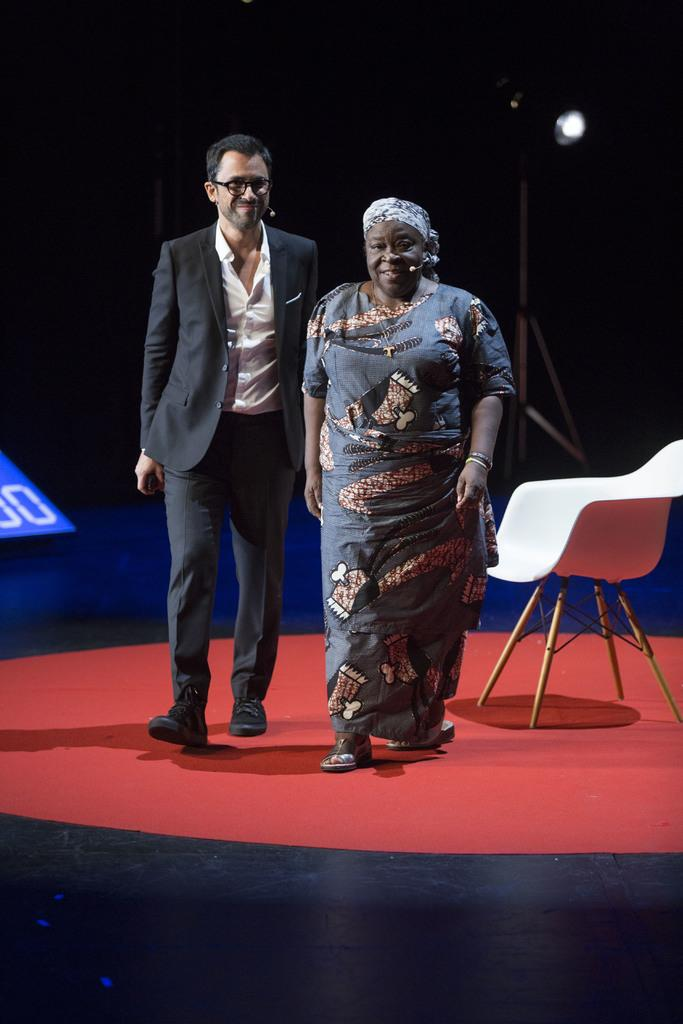What types of people are present in the image? There are women and men in the image. What are the women and men doing in the image? The women and men are walking on a stage and laughing. What type of instrument is being played by the bird in the image? There is no bird or instrument present in the image. How does the earthquake affect the stage in the image? There is no earthquake present in the image, so it cannot affect the stage. 